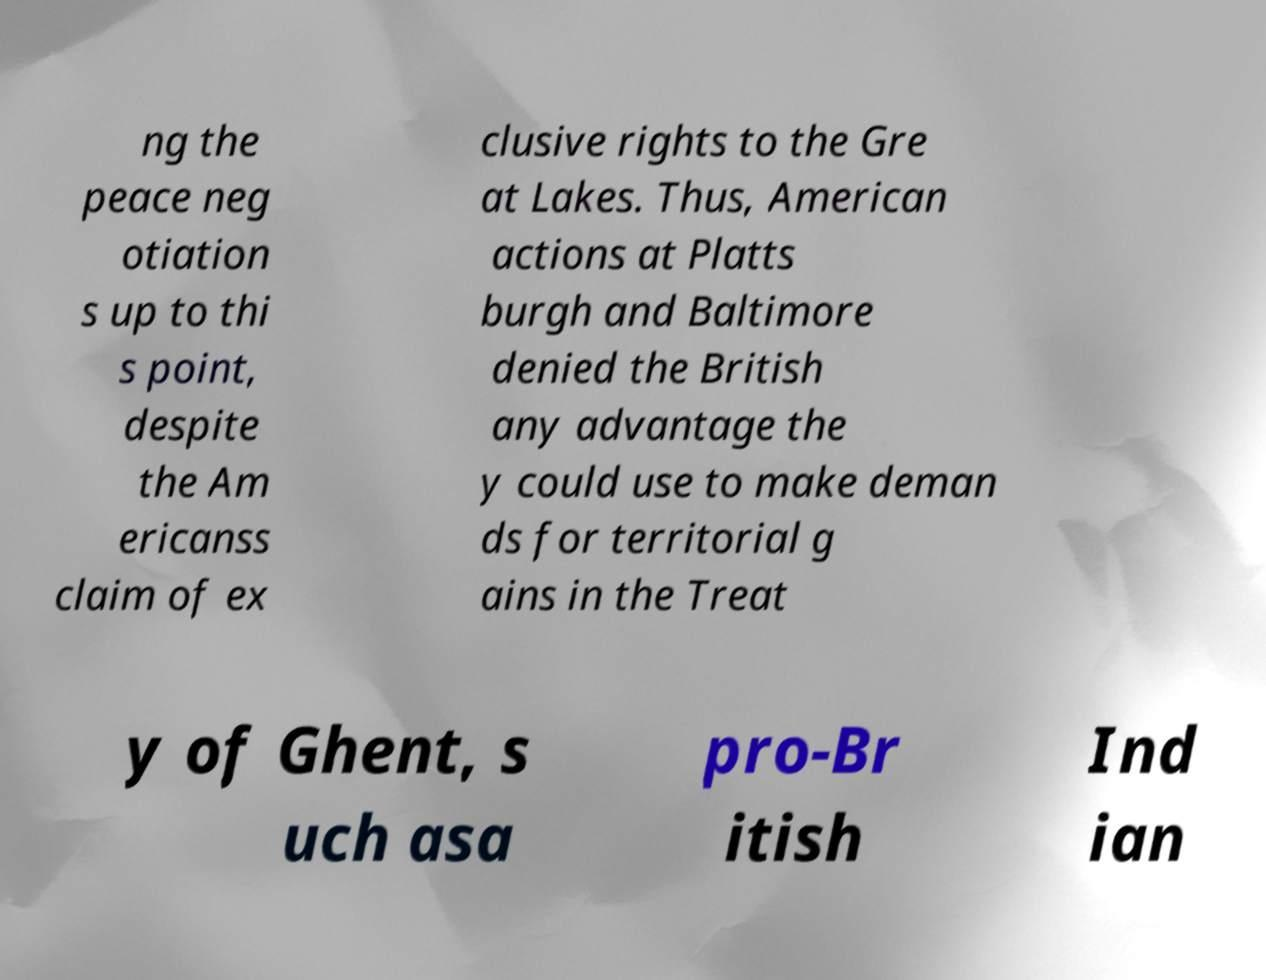What messages or text are displayed in this image? I need them in a readable, typed format. ng the peace neg otiation s up to thi s point, despite the Am ericanss claim of ex clusive rights to the Gre at Lakes. Thus, American actions at Platts burgh and Baltimore denied the British any advantage the y could use to make deman ds for territorial g ains in the Treat y of Ghent, s uch asa pro-Br itish Ind ian 